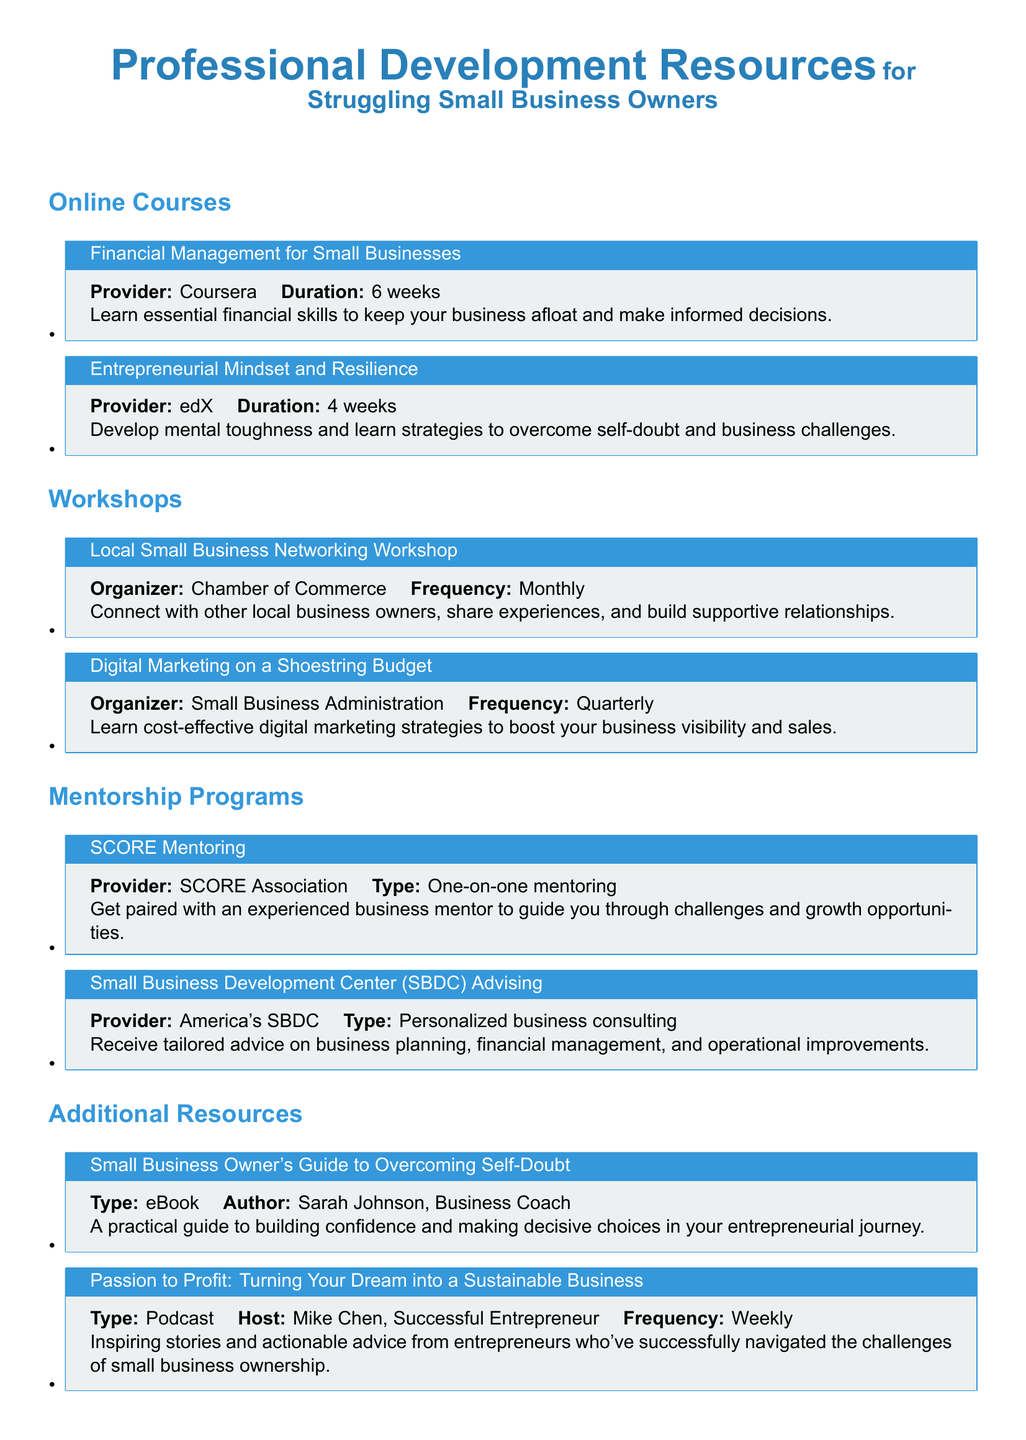What is the online course that focuses on financial management? The online course that focuses on financial management is listed under Online Courses with the title provided, which is Financial Management for Small Businesses.
Answer: Financial Management for Small Businesses Who organizes the Local Small Business Networking Workshop? The organizer of this workshop is mentioned in the document, which is the Chamber of Commerce.
Answer: Chamber of Commerce How often is the Digital Marketing on a Shoestring Budget workshop held? The document specifies the frequency of this workshop, indicating it occurs quarterly.
Answer: Quarterly What type of mentoring does SCORE provide? The document describes SCORE Mentoring as providing one-on-one mentoring, clarifying the format of the mentorship.
Answer: One-on-one mentoring What resource type is the Small Business Owner's Guide to Overcoming Self-Doubt? The document categorizes this specific resource as an eBook, indicating its format.
Answer: eBook How many weeks does the Entrepreneurial Mindset and Resilience course last? The duration of this online course is explicitly mentioned in the document as four weeks.
Answer: 4 weeks What is the frequency of the Passion to Profit podcast? The document states the podcast's release frequency, indicating it is produced weekly.
Answer: Weekly Which organization provides the Small Business Development Center (SBDC) Advising? The document cites the provider of this advising service, which is America's SBDC.
Answer: America's SBDC 